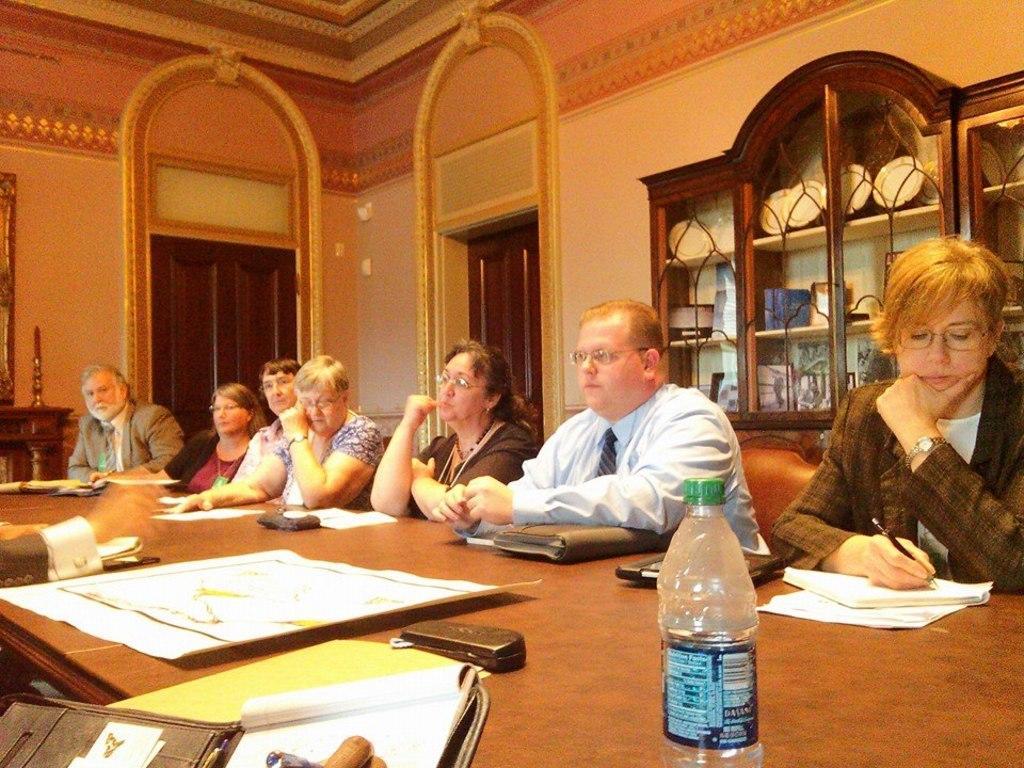Please provide a concise description of this image. In the image we can see few persons were sitting on the chair around the a table. And the right corner lady she is writing something on the paper. In front bottom there is a water bottle and on the table there is some objects like paper, book etc. And coming to the background there is a wall. And back them there is a shelf with few objects. 